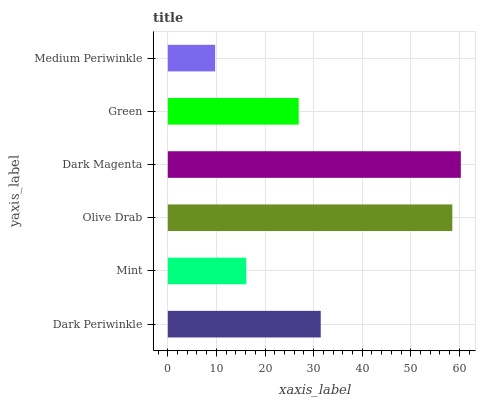Is Medium Periwinkle the minimum?
Answer yes or no. Yes. Is Dark Magenta the maximum?
Answer yes or no. Yes. Is Mint the minimum?
Answer yes or no. No. Is Mint the maximum?
Answer yes or no. No. Is Dark Periwinkle greater than Mint?
Answer yes or no. Yes. Is Mint less than Dark Periwinkle?
Answer yes or no. Yes. Is Mint greater than Dark Periwinkle?
Answer yes or no. No. Is Dark Periwinkle less than Mint?
Answer yes or no. No. Is Dark Periwinkle the high median?
Answer yes or no. Yes. Is Green the low median?
Answer yes or no. Yes. Is Olive Drab the high median?
Answer yes or no. No. Is Olive Drab the low median?
Answer yes or no. No. 